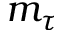<formula> <loc_0><loc_0><loc_500><loc_500>m _ { \tau }</formula> 